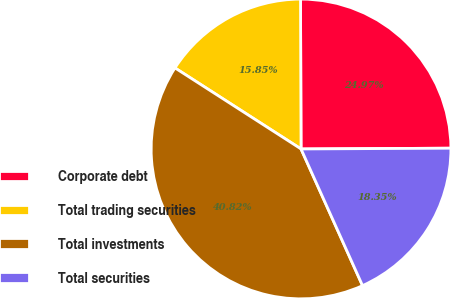Convert chart to OTSL. <chart><loc_0><loc_0><loc_500><loc_500><pie_chart><fcel>Corporate debt<fcel>Total trading securities<fcel>Total investments<fcel>Total securities<nl><fcel>24.97%<fcel>15.85%<fcel>40.82%<fcel>18.35%<nl></chart> 